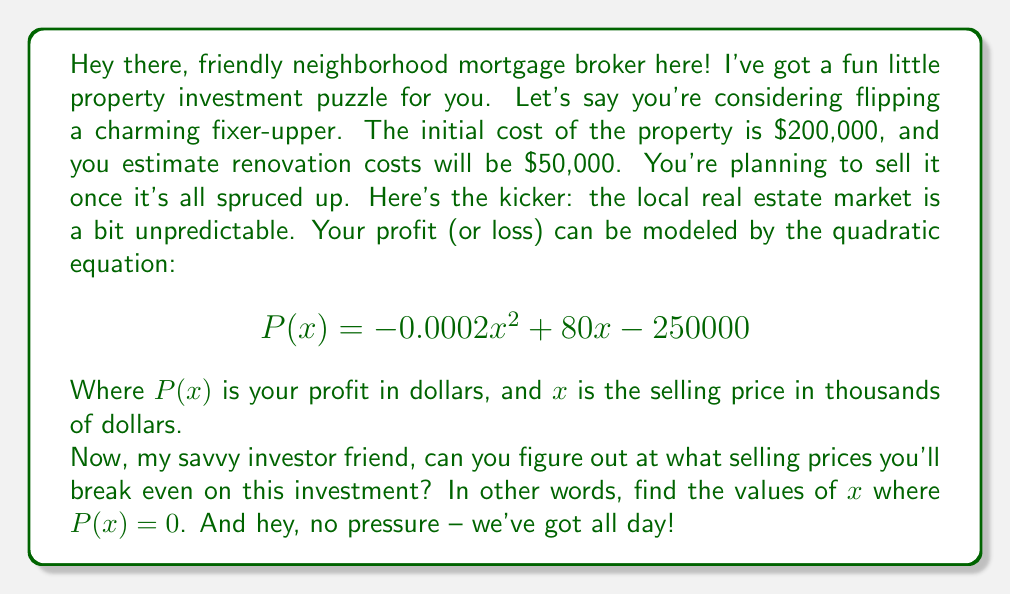Teach me how to tackle this problem. Alright, let's break this down step-by-step, shall we? We're looking for the break-even points, which means we need to solve the quadratic equation when $P(x) = 0$. Here's how we do it:

1) We start with our equation:
   $$-0.0002x^2 + 80x - 250000 = 0$$

2) This is in the standard form of a quadratic equation: $ax^2 + bx + c = 0$
   Where $a = -0.0002$, $b = 80$, and $c = -250000$

3) To solve this, we'll use the quadratic formula: $x = \frac{-b \pm \sqrt{b^2 - 4ac}}{2a}$

4) Let's substitute our values:
   $$x = \frac{-80 \pm \sqrt{80^2 - 4(-0.0002)(-250000)}}{2(-0.0002)}$$

5) Simplify inside the square root:
   $$x = \frac{-80 \pm \sqrt{6400 - 200}}{-0.0004}$$
   $$x = \frac{-80 \pm \sqrt{6200}}{-0.0004}$$

6) Simplify further:
   $$x = \frac{-80 \pm 78.74}{-0.0004}$$

7) Now we have two solutions:
   $$x = \frac{-80 + 78.74}{-0.0004} \text{ or } x = \frac{-80 - 78.74}{-0.0004}$$

8) Simplify:
   $$x = \frac{-1.26}{-0.0004} \text{ or } x = \frac{-158.74}{-0.0004}$$

9) Calculate the final values:
   $$x \approx 3150 \text{ or } x \approx 396850$$

Remember, $x$ is in thousands of dollars, so we need to multiply these values by 1000.
Answer: The break-even selling prices are approximately $3,150,000 and $396,850,000. This means you'll break even if you sell the property for either of these amounts. Anything between these two prices will result in a profit, while selling below $3,150,000 or above $396,850,000 would result in a loss. 